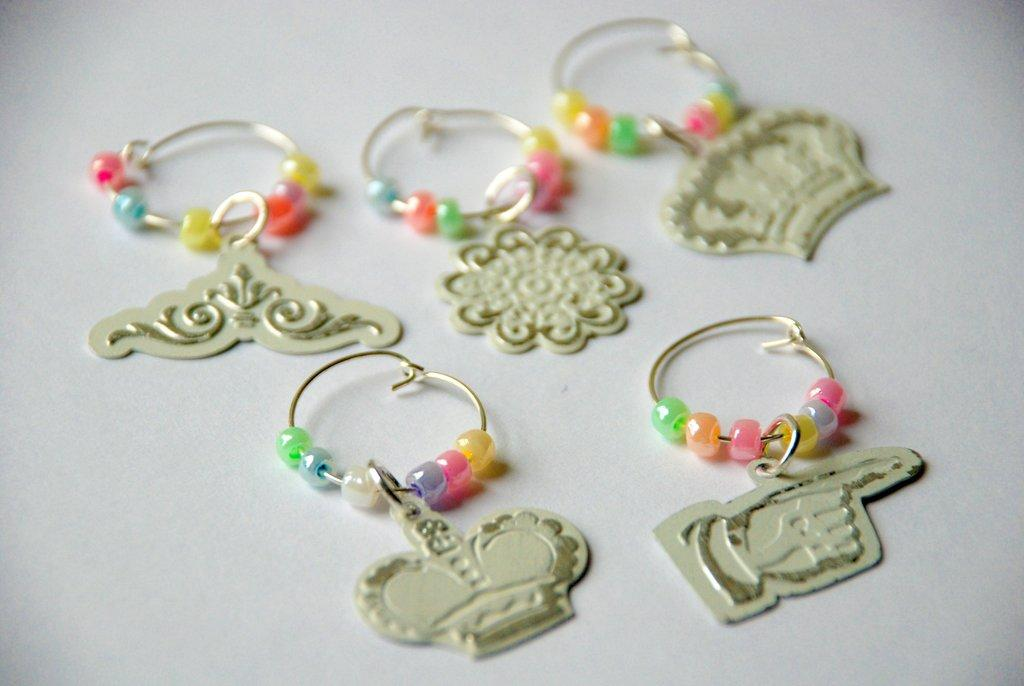How many earrings are visible in the image? There are five earrings in the image. Where are the earrings located? The earrings are on an object. What type of rod is being used by the partner in the image? There is no rod or partner present in the image; it only features five earrings on an object. 